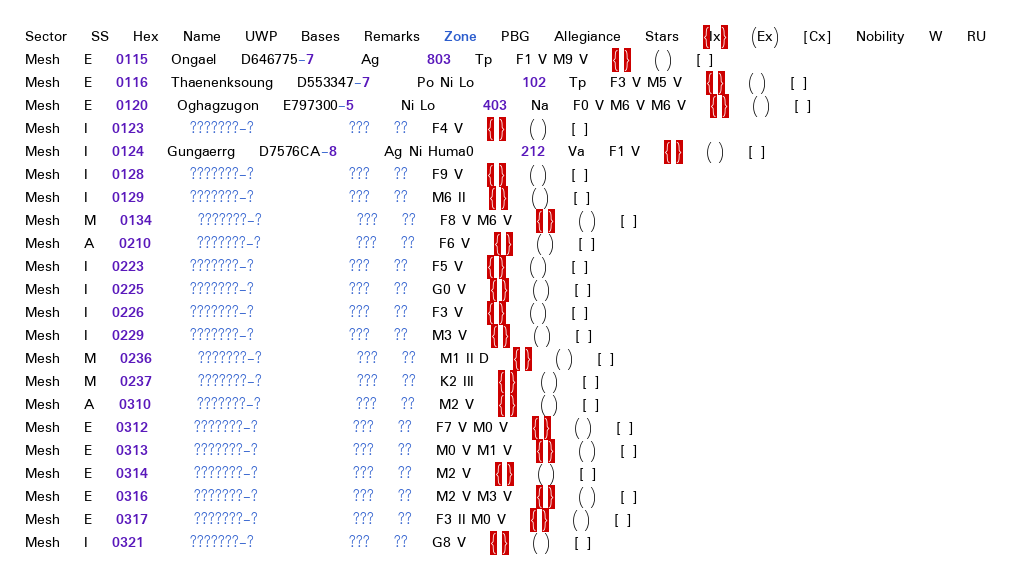Convert code to text. <code><loc_0><loc_0><loc_500><loc_500><_SQL_>Sector	SS	Hex	Name	UWP	Bases	Remarks	Zone	PBG	Allegiance	Stars	{Ix}	(Ex)	[Cx]	Nobility	W	RU
Mesh	E	0115	Ongael	D646775-7	 	Ag		803	Tp	F1 V M9 V	{ }	( )	[ ]		 	 
Mesh	E	0116	Thaenenksoung 	D553347-7	 	Po Ni Lo		102	Tp	F3 V M5 V	{ }	( )	[ ]		 	 
Mesh	E	0120	 Oghagzugon	E797300-5	 	Ni Lo		403	Na	F0 V M6 V M6 V	{ }	( )	[ ]		 	 
Mesh	I	0123	 	???????-?	 	 		???	??	F4 V	{ }	( )	[ ]		 	 
Mesh	I	0124	Gungaerrg	D7576CA-8	 	Ag Ni Huma0		212	Va	F1 V	{ }	( )	[ ]		 	 
Mesh	I	0128	 	???????-?	 	 		???	??	F9 V	{ }	( )	[ ]		 	 
Mesh	I	0129	 	???????-?	 	 		???	??	M6 II	{ }	( )	[ ]		 	 
Mesh	M	0134	 	???????-?	 	 		???	??	F8 V M6 V	{ }	( )	[ ]		 	 
Mesh	A	0210	 	???????-?	 	 		???	??	F6 V	{ }	( )	[ ]		 	 
Mesh	I	0223	 	???????-?	 	 		???	??	F5 V	{ }	( )	[ ]		 	 
Mesh	I	0225	 	???????-?	 	 		???	??	G0 V	{ }	( )	[ ]		 	 
Mesh	I	0226	 	???????-?	 	 		???	??	F3 V	{ }	( )	[ ]		 	 
Mesh	I	0229	 	???????-?	 	 		???	??	M3 V	{ }	( )	[ ]		 	 
Mesh	M	0236	 	???????-?	 	 		???	??	M1 II D	{ }	( )	[ ]		 	 
Mesh	M	0237	 	???????-?	 	 		???	??	K2 III	{ }	( )	[ ]		 	 
Mesh	A	0310	 	???????-?	 	 		???	??	M2 V	{ }	( )	[ ]		 	 
Mesh	E	0312	 	???????-?	 	 		???	??	F7 V M0 V	{ }	( )	[ ]		 	 
Mesh	E	0313	 	???????-?	 	 		???	??	M0 V M1 V	{ }	( )	[ ]		 	 
Mesh	E	0314	 	???????-?	 	 		???	??	M2 V	{ }	( )	[ ]		 	 
Mesh	E	0316	 	???????-?	 	 		???	??	M2 V M3 V	{ }	( )	[ ]		 	 
Mesh	E	0317	 	???????-?	 	 		???	??	F3 II M0 V	{ }	( )	[ ]		 	 
Mesh	I	0321	 	???????-?	 	 		???	??	G8 V	{ }	( )	[ ]		 	 </code> 